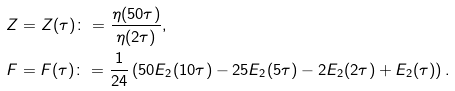Convert formula to latex. <formula><loc_0><loc_0><loc_500><loc_500>& Z = Z ( \tau ) \colon = \frac { \eta ( 5 0 \tau ) } { \eta ( 2 \tau ) } , \\ & F = F ( \tau ) \colon = \frac { 1 } { 2 4 } \left ( 5 0 E _ { 2 } ( 1 0 \tau ) - 2 5 E _ { 2 } ( 5 \tau ) - 2 E _ { 2 } ( 2 \tau ) + E _ { 2 } ( \tau ) \right ) .</formula> 